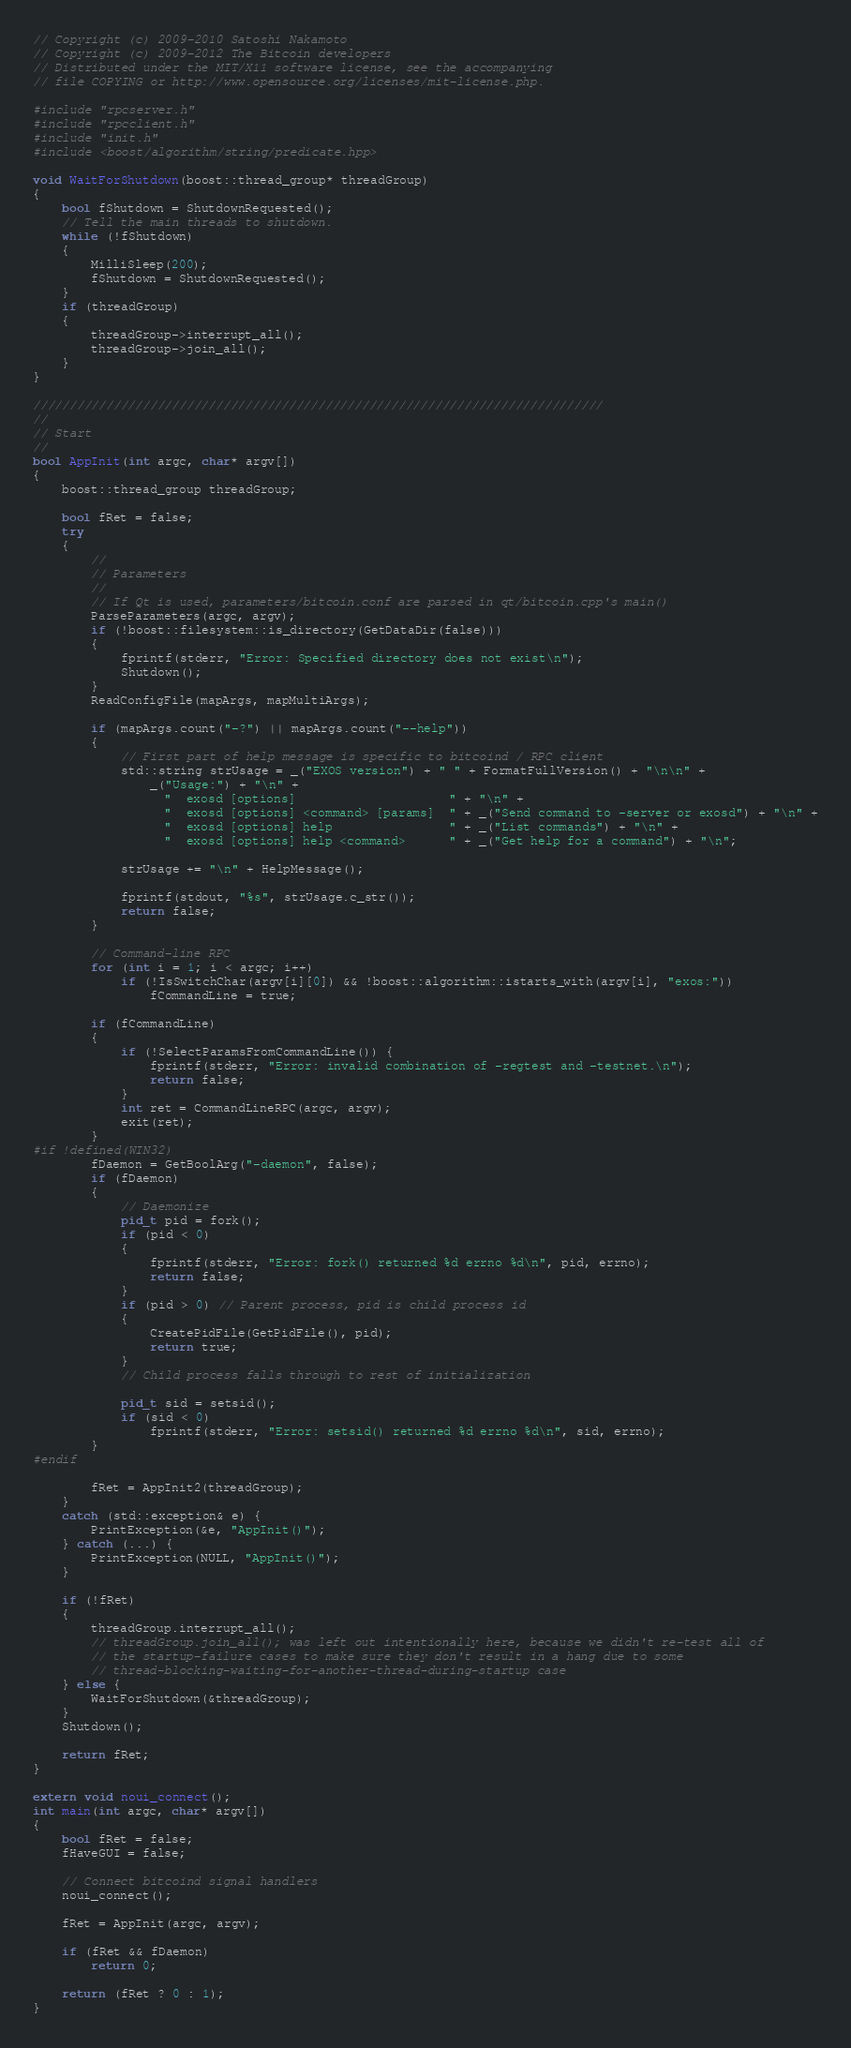<code> <loc_0><loc_0><loc_500><loc_500><_C++_>// Copyright (c) 2009-2010 Satoshi Nakamoto
// Copyright (c) 2009-2012 The Bitcoin developers
// Distributed under the MIT/X11 software license, see the accompanying
// file COPYING or http://www.opensource.org/licenses/mit-license.php.

#include "rpcserver.h"
#include "rpcclient.h"
#include "init.h"
#include <boost/algorithm/string/predicate.hpp>

void WaitForShutdown(boost::thread_group* threadGroup)
{
    bool fShutdown = ShutdownRequested();
    // Tell the main threads to shutdown.
    while (!fShutdown)
    {
        MilliSleep(200);
        fShutdown = ShutdownRequested();
    }
    if (threadGroup)
    {
        threadGroup->interrupt_all();
        threadGroup->join_all();
    }
}

//////////////////////////////////////////////////////////////////////////////
//
// Start
//
bool AppInit(int argc, char* argv[])
{
    boost::thread_group threadGroup;

    bool fRet = false;
    try
    {
        //
        // Parameters
        //
        // If Qt is used, parameters/bitcoin.conf are parsed in qt/bitcoin.cpp's main()
        ParseParameters(argc, argv);
        if (!boost::filesystem::is_directory(GetDataDir(false)))
        {
            fprintf(stderr, "Error: Specified directory does not exist\n");
            Shutdown();
        }
        ReadConfigFile(mapArgs, mapMultiArgs);

        if (mapArgs.count("-?") || mapArgs.count("--help"))
        {
            // First part of help message is specific to bitcoind / RPC client
            std::string strUsage = _("EXOS version") + " " + FormatFullVersion() + "\n\n" +
                _("Usage:") + "\n" +
                  "  exosd [options]                     " + "\n" +
                  "  exosd [options] <command> [params]  " + _("Send command to -server or exosd") + "\n" +
                  "  exosd [options] help                " + _("List commands") + "\n" +
                  "  exosd [options] help <command>      " + _("Get help for a command") + "\n";

            strUsage += "\n" + HelpMessage();

            fprintf(stdout, "%s", strUsage.c_str());
            return false;
        }

        // Command-line RPC
        for (int i = 1; i < argc; i++)
            if (!IsSwitchChar(argv[i][0]) && !boost::algorithm::istarts_with(argv[i], "exos:"))
                fCommandLine = true;

        if (fCommandLine)
        {
            if (!SelectParamsFromCommandLine()) {
                fprintf(stderr, "Error: invalid combination of -regtest and -testnet.\n");
                return false;
            }
            int ret = CommandLineRPC(argc, argv);
            exit(ret);
        }
#if !defined(WIN32)
        fDaemon = GetBoolArg("-daemon", false);
        if (fDaemon)
        {
            // Daemonize
            pid_t pid = fork();
            if (pid < 0)
            {
                fprintf(stderr, "Error: fork() returned %d errno %d\n", pid, errno);
                return false;
            }
            if (pid > 0) // Parent process, pid is child process id
            {
                CreatePidFile(GetPidFile(), pid);
                return true;
            }
            // Child process falls through to rest of initialization

            pid_t sid = setsid();
            if (sid < 0)
                fprintf(stderr, "Error: setsid() returned %d errno %d\n", sid, errno);
        }
#endif

        fRet = AppInit2(threadGroup);
    }
    catch (std::exception& e) {
        PrintException(&e, "AppInit()");
    } catch (...) {
        PrintException(NULL, "AppInit()");
    }

    if (!fRet)
    {
        threadGroup.interrupt_all();
        // threadGroup.join_all(); was left out intentionally here, because we didn't re-test all of
        // the startup-failure cases to make sure they don't result in a hang due to some
        // thread-blocking-waiting-for-another-thread-during-startup case
    } else {
        WaitForShutdown(&threadGroup);
    }
    Shutdown();

    return fRet;
}

extern void noui_connect();
int main(int argc, char* argv[])
{
    bool fRet = false;
    fHaveGUI = false;

    // Connect bitcoind signal handlers
    noui_connect();

    fRet = AppInit(argc, argv);

    if (fRet && fDaemon)
        return 0;

    return (fRet ? 0 : 1);
}
</code> 